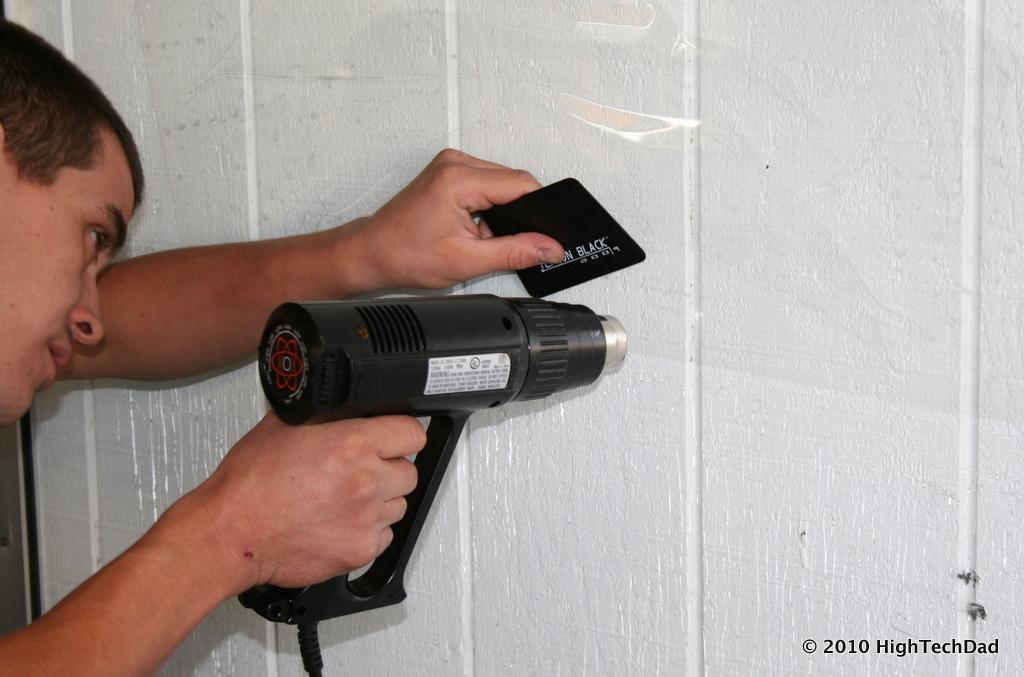Please provide a concise description of this image. This picture shows that a man is drilling a hole in the wall with black color drill machine. 